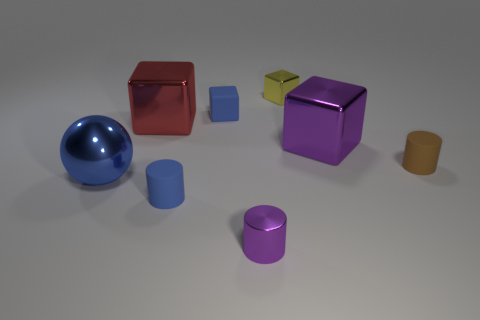Add 1 large gray objects. How many objects exist? 9 Subtract all balls. How many objects are left? 7 Subtract all purple cylinders. Subtract all big red shiny objects. How many objects are left? 6 Add 5 small rubber objects. How many small rubber objects are left? 8 Add 6 large objects. How many large objects exist? 9 Subtract 0 green balls. How many objects are left? 8 